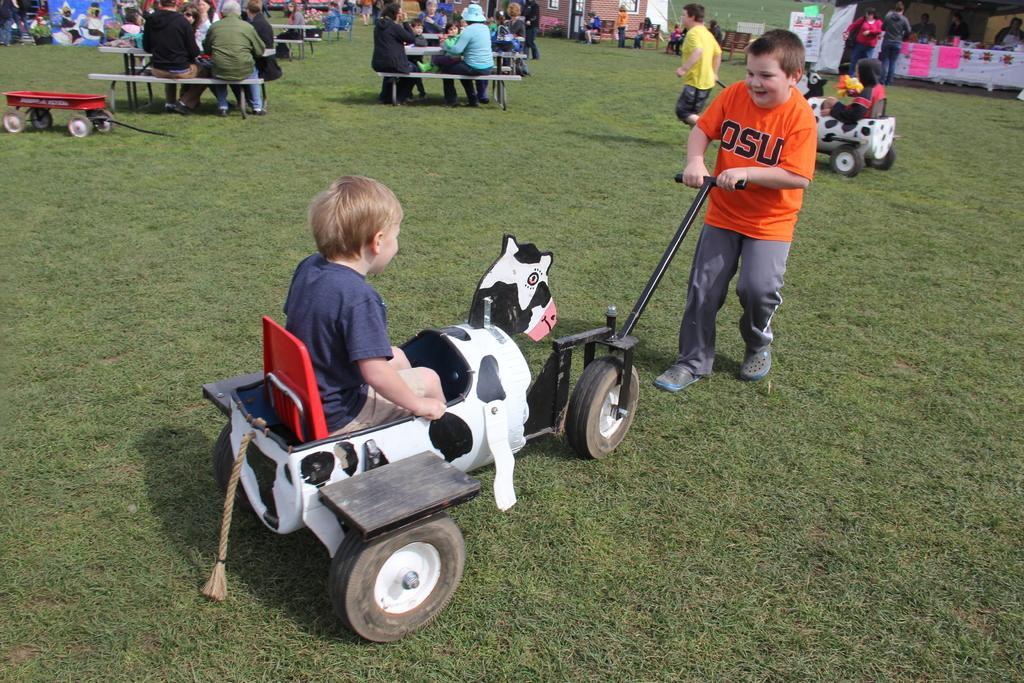Could you give a brief overview of what you see in this image? In this picture we can see a group of people on the ground, here we can see toy vehicles, benches and some objects. 